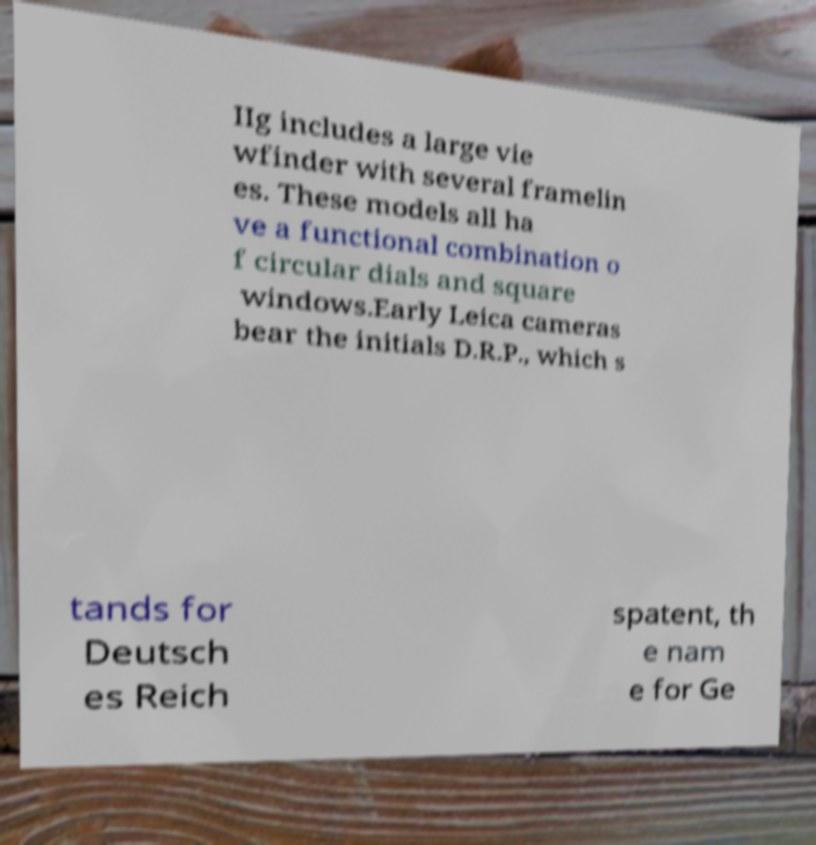Could you assist in decoding the text presented in this image and type it out clearly? IIg includes a large vie wfinder with several framelin es. These models all ha ve a functional combination o f circular dials and square windows.Early Leica cameras bear the initials D.R.P., which s tands for Deutsch es Reich spatent, th e nam e for Ge 